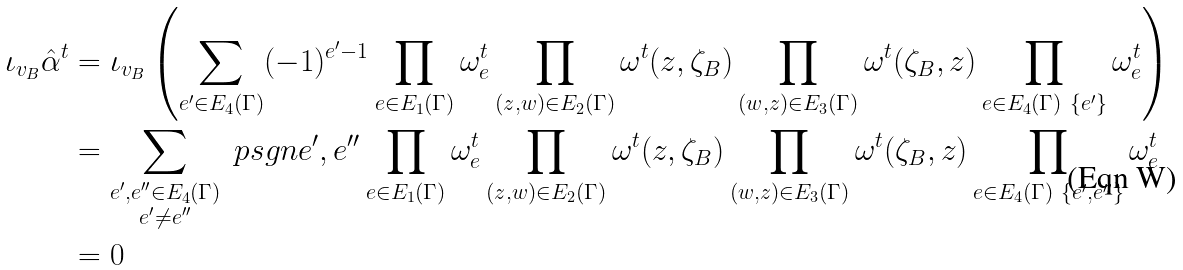Convert formula to latex. <formula><loc_0><loc_0><loc_500><loc_500>\iota _ { v _ { B } } \hat { \alpha } ^ { t } & = \iota _ { v _ { B } } \left ( \sum _ { e ^ { \prime } \in E _ { 4 } ( \Gamma ) } ( - 1 ) ^ { e ^ { \prime } - 1 } \prod _ { e \in E _ { 1 } ( \Gamma ) } \omega ^ { t } _ { e } \prod _ { ( z , w ) \in E _ { 2 } ( \Gamma ) } \omega ^ { t } ( z , \zeta _ { B } ) \prod _ { ( w , z ) \in E _ { 3 } ( \Gamma ) } \omega ^ { t } ( \zeta _ { B } , z ) \prod _ { e \in E _ { 4 } ( \Gamma ) \ \{ e ^ { \prime } \} } \omega ^ { t } _ { e } \right ) \\ & = \sum _ { \substack { e ^ { \prime } , e ^ { \prime \prime } \in E _ { 4 } ( \Gamma ) \\ e ^ { \prime } \neq e ^ { \prime \prime } } } \ p s g n { e ^ { \prime } , e ^ { \prime \prime } } \prod _ { e \in E _ { 1 } ( \Gamma ) } \omega ^ { t } _ { e } \prod _ { ( z , w ) \in E _ { 2 } ( \Gamma ) } \omega ^ { t } ( z , \zeta _ { B } ) \prod _ { ( w , z ) \in E _ { 3 } ( \Gamma ) } \omega ^ { t } ( \zeta _ { B } , z ) \prod _ { e \in E _ { 4 } ( \Gamma ) \ \{ e ^ { \prime } , e ^ { \prime \prime } \} } \omega ^ { t } _ { e } \\ & = 0</formula> 